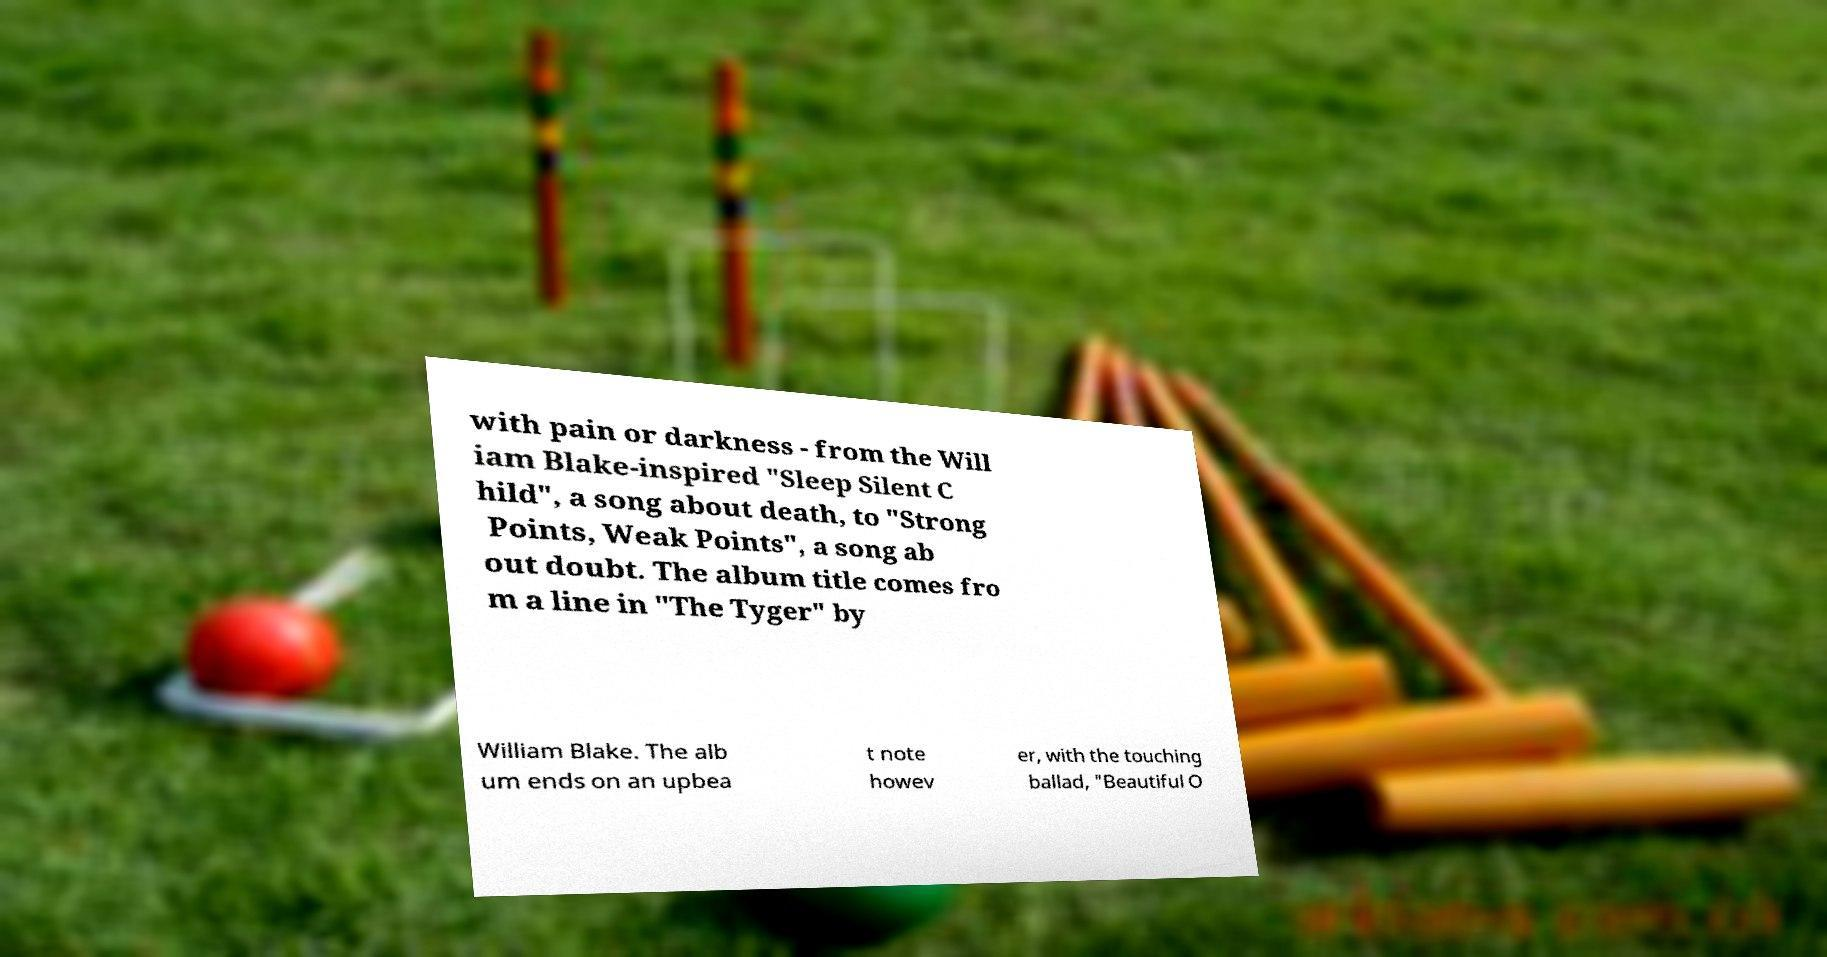There's text embedded in this image that I need extracted. Can you transcribe it verbatim? with pain or darkness - from the Will iam Blake-inspired "Sleep Silent C hild", a song about death, to "Strong Points, Weak Points", a song ab out doubt. The album title comes fro m a line in "The Tyger" by William Blake. The alb um ends on an upbea t note howev er, with the touching ballad, "Beautiful O 